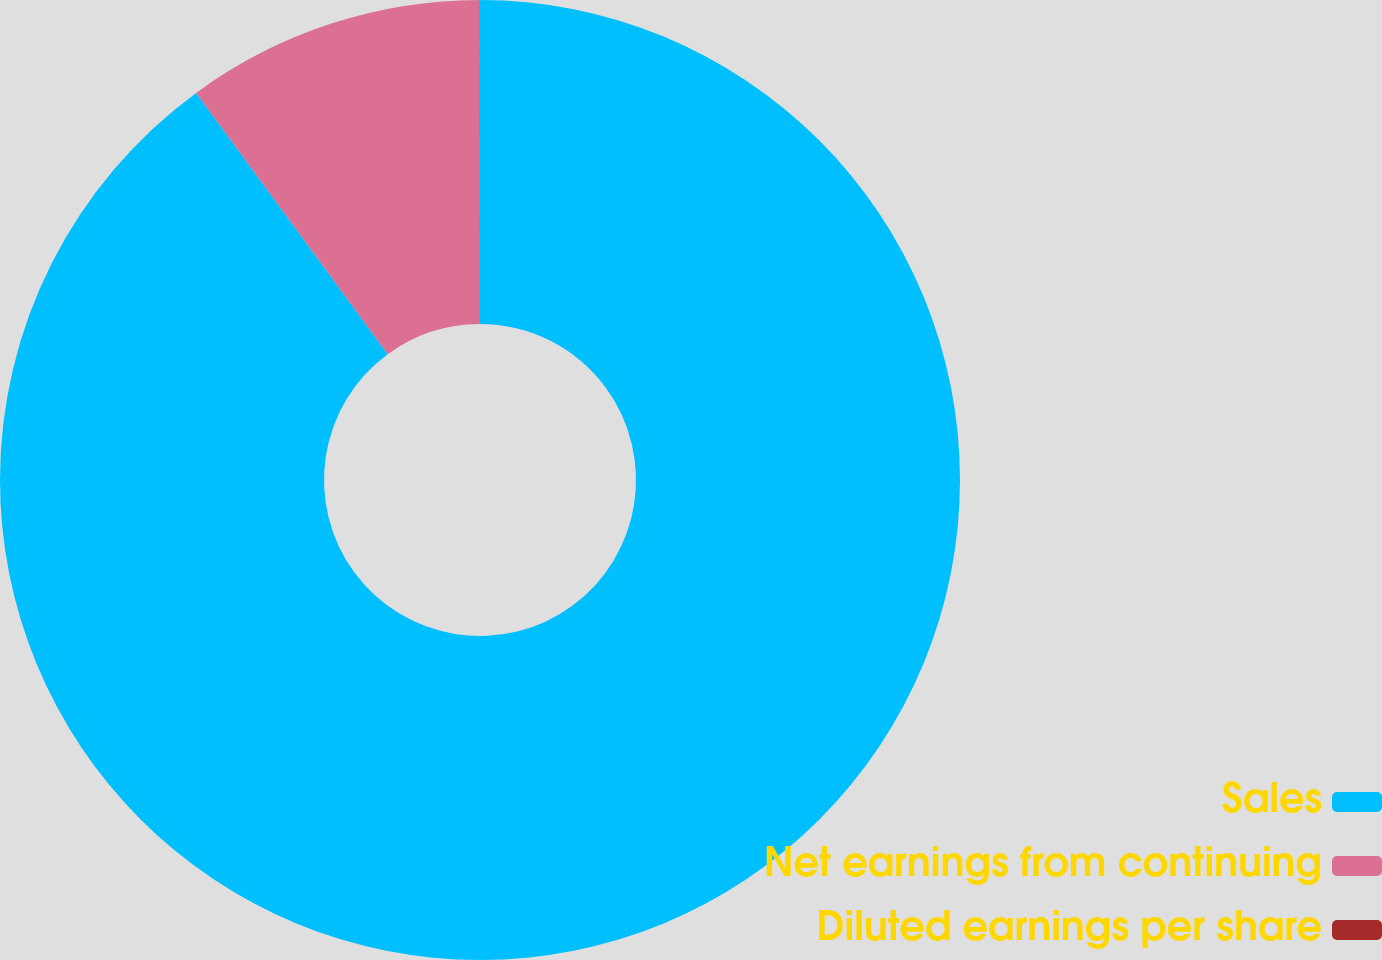Convert chart to OTSL. <chart><loc_0><loc_0><loc_500><loc_500><pie_chart><fcel>Sales<fcel>Net earnings from continuing<fcel>Diluted earnings per share<nl><fcel>89.93%<fcel>10.06%<fcel>0.01%<nl></chart> 